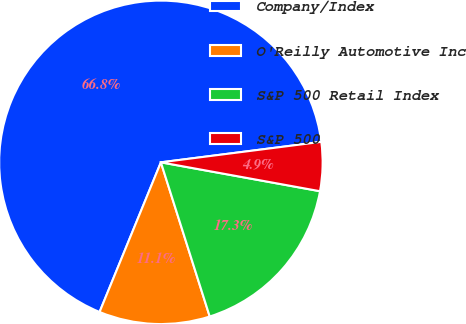Convert chart to OTSL. <chart><loc_0><loc_0><loc_500><loc_500><pie_chart><fcel>Company/Index<fcel>O'Reilly Automotive Inc<fcel>S&P 500 Retail Index<fcel>S&P 500<nl><fcel>66.79%<fcel>11.07%<fcel>17.26%<fcel>4.88%<nl></chart> 